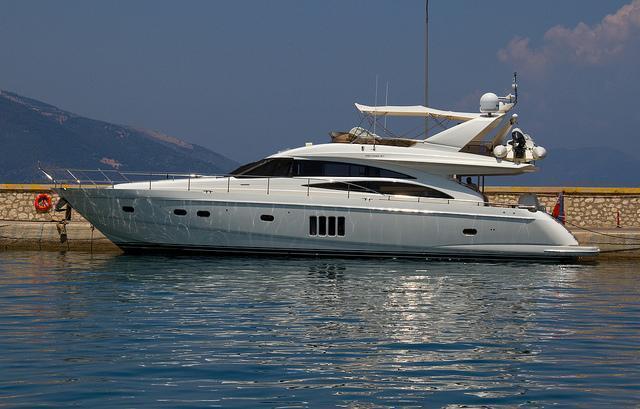How many donuts are on the plate?
Give a very brief answer. 0. 